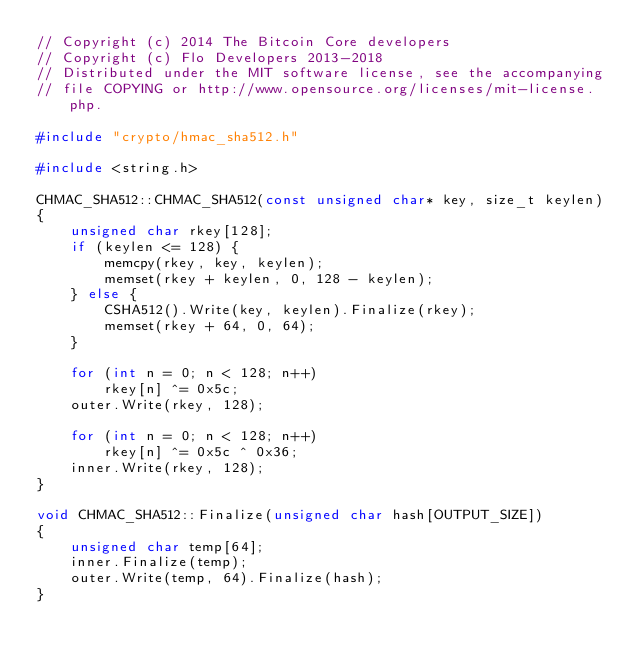<code> <loc_0><loc_0><loc_500><loc_500><_C++_>// Copyright (c) 2014 The Bitcoin Core developers
// Copyright (c) Flo Developers 2013-2018
// Distributed under the MIT software license, see the accompanying
// file COPYING or http://www.opensource.org/licenses/mit-license.php.

#include "crypto/hmac_sha512.h"

#include <string.h>

CHMAC_SHA512::CHMAC_SHA512(const unsigned char* key, size_t keylen)
{
    unsigned char rkey[128];
    if (keylen <= 128) {
        memcpy(rkey, key, keylen);
        memset(rkey + keylen, 0, 128 - keylen);
    } else {
        CSHA512().Write(key, keylen).Finalize(rkey);
        memset(rkey + 64, 0, 64);
    }

    for (int n = 0; n < 128; n++)
        rkey[n] ^= 0x5c;
    outer.Write(rkey, 128);

    for (int n = 0; n < 128; n++)
        rkey[n] ^= 0x5c ^ 0x36;
    inner.Write(rkey, 128);
}

void CHMAC_SHA512::Finalize(unsigned char hash[OUTPUT_SIZE])
{
    unsigned char temp[64];
    inner.Finalize(temp);
    outer.Write(temp, 64).Finalize(hash);
}
</code> 